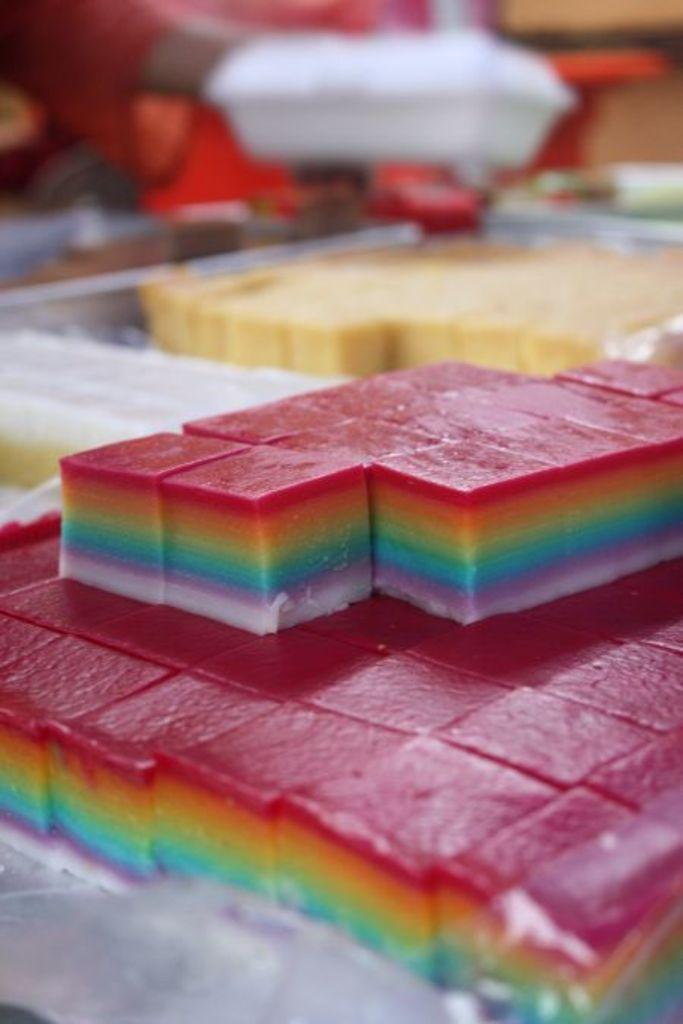What types of sweets are present in the image? There are lollies and cakes in the image. Can you describe the background of the image? The background of the image is blurred. What is the color of the cake that won the competition in the image? There is no competition present in the image, and therefore no cake has won anything. 